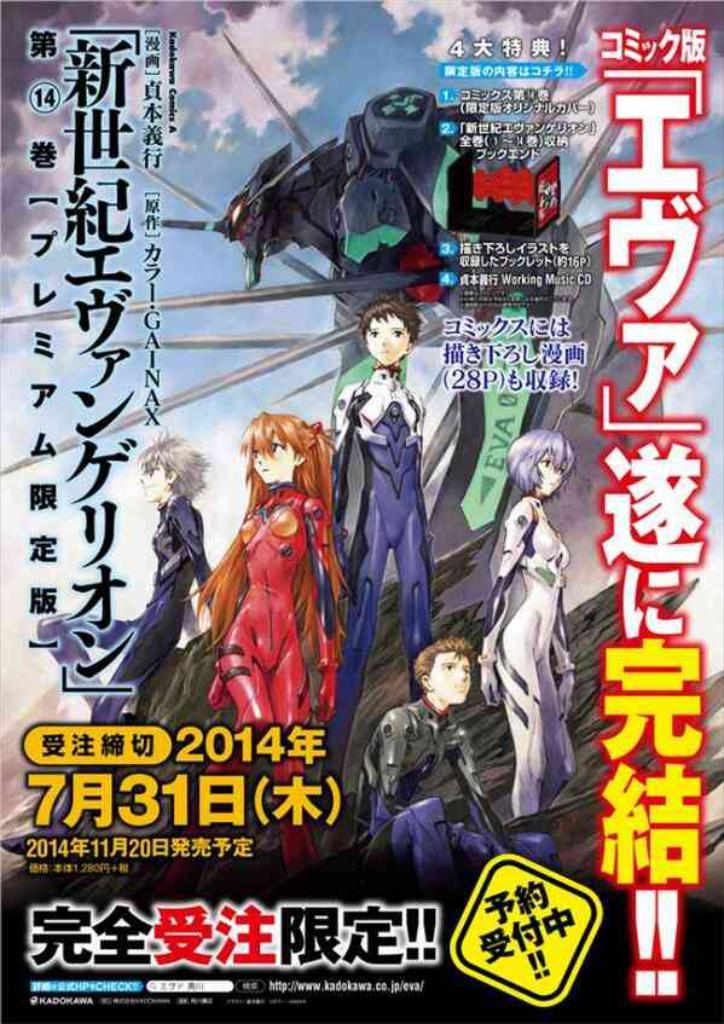What type of image is being described? The image is a poster. What can be seen in the poster? There are animated characters in the poster. Are there any words or letters in the poster? Yes, there is text in the poster. What type of education can be seen in the middle of the poster? There is no reference to education in the image, as it features animated characters and text. 